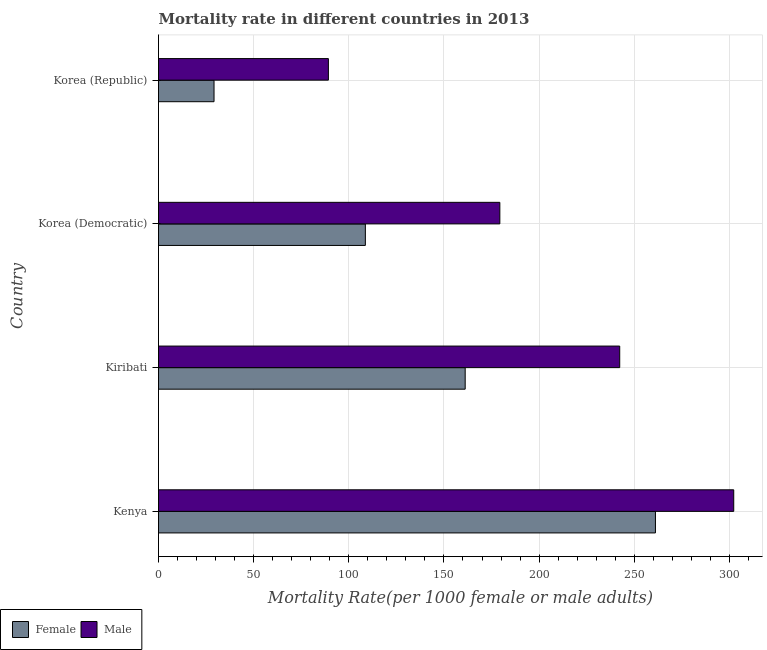How many groups of bars are there?
Keep it short and to the point. 4. How many bars are there on the 1st tick from the bottom?
Make the answer very short. 2. What is the label of the 4th group of bars from the top?
Make the answer very short. Kenya. What is the male mortality rate in Korea (Democratic)?
Your answer should be compact. 179.37. Across all countries, what is the maximum female mortality rate?
Keep it short and to the point. 261.13. Across all countries, what is the minimum male mortality rate?
Offer a terse response. 89.27. In which country was the male mortality rate maximum?
Your response must be concise. Kenya. In which country was the male mortality rate minimum?
Provide a succinct answer. Korea (Republic). What is the total male mortality rate in the graph?
Your answer should be compact. 813.26. What is the difference between the female mortality rate in Korea (Democratic) and that in Korea (Republic)?
Your answer should be compact. 79.52. What is the difference between the female mortality rate in Korea (Democratic) and the male mortality rate in Kiribati?
Provide a short and direct response. -133.66. What is the average male mortality rate per country?
Your response must be concise. 203.32. What is the difference between the male mortality rate and female mortality rate in Kenya?
Keep it short and to the point. 41.14. What is the ratio of the female mortality rate in Kenya to that in Korea (Republic)?
Offer a very short reply. 8.95. What is the difference between the highest and the second highest male mortality rate?
Give a very brief answer. 59.92. What is the difference between the highest and the lowest male mortality rate?
Offer a very short reply. 213. In how many countries, is the male mortality rate greater than the average male mortality rate taken over all countries?
Provide a short and direct response. 2. What does the 1st bar from the top in Kiribati represents?
Make the answer very short. Male. Are all the bars in the graph horizontal?
Provide a succinct answer. Yes. How many countries are there in the graph?
Offer a terse response. 4. What is the difference between two consecutive major ticks on the X-axis?
Provide a short and direct response. 50. Where does the legend appear in the graph?
Make the answer very short. Bottom left. How many legend labels are there?
Your response must be concise. 2. What is the title of the graph?
Your response must be concise. Mortality rate in different countries in 2013. Does "Savings" appear as one of the legend labels in the graph?
Your answer should be very brief. No. What is the label or title of the X-axis?
Your response must be concise. Mortality Rate(per 1000 female or male adults). What is the Mortality Rate(per 1000 female or male adults) in Female in Kenya?
Your answer should be compact. 261.13. What is the Mortality Rate(per 1000 female or male adults) in Male in Kenya?
Your answer should be compact. 302.27. What is the Mortality Rate(per 1000 female or male adults) in Female in Kiribati?
Ensure brevity in your answer.  161.15. What is the Mortality Rate(per 1000 female or male adults) of Male in Kiribati?
Provide a succinct answer. 242.35. What is the Mortality Rate(per 1000 female or male adults) of Female in Korea (Democratic)?
Your answer should be compact. 108.69. What is the Mortality Rate(per 1000 female or male adults) of Male in Korea (Democratic)?
Provide a short and direct response. 179.37. What is the Mortality Rate(per 1000 female or male adults) in Female in Korea (Republic)?
Your response must be concise. 29.17. What is the Mortality Rate(per 1000 female or male adults) of Male in Korea (Republic)?
Keep it short and to the point. 89.27. Across all countries, what is the maximum Mortality Rate(per 1000 female or male adults) in Female?
Provide a short and direct response. 261.13. Across all countries, what is the maximum Mortality Rate(per 1000 female or male adults) in Male?
Give a very brief answer. 302.27. Across all countries, what is the minimum Mortality Rate(per 1000 female or male adults) of Female?
Offer a very short reply. 29.17. Across all countries, what is the minimum Mortality Rate(per 1000 female or male adults) in Male?
Your answer should be very brief. 89.27. What is the total Mortality Rate(per 1000 female or male adults) in Female in the graph?
Provide a short and direct response. 560.14. What is the total Mortality Rate(per 1000 female or male adults) in Male in the graph?
Give a very brief answer. 813.26. What is the difference between the Mortality Rate(per 1000 female or male adults) of Female in Kenya and that in Kiribati?
Offer a very short reply. 99.98. What is the difference between the Mortality Rate(per 1000 female or male adults) in Male in Kenya and that in Kiribati?
Make the answer very short. 59.92. What is the difference between the Mortality Rate(per 1000 female or male adults) of Female in Kenya and that in Korea (Democratic)?
Your answer should be very brief. 152.44. What is the difference between the Mortality Rate(per 1000 female or male adults) in Male in Kenya and that in Korea (Democratic)?
Provide a short and direct response. 122.9. What is the difference between the Mortality Rate(per 1000 female or male adults) in Female in Kenya and that in Korea (Republic)?
Your response must be concise. 231.96. What is the difference between the Mortality Rate(per 1000 female or male adults) in Male in Kenya and that in Korea (Republic)?
Ensure brevity in your answer.  213. What is the difference between the Mortality Rate(per 1000 female or male adults) in Female in Kiribati and that in Korea (Democratic)?
Your answer should be compact. 52.46. What is the difference between the Mortality Rate(per 1000 female or male adults) in Male in Kiribati and that in Korea (Democratic)?
Your answer should be very brief. 62.99. What is the difference between the Mortality Rate(per 1000 female or male adults) in Female in Kiribati and that in Korea (Republic)?
Make the answer very short. 131.98. What is the difference between the Mortality Rate(per 1000 female or male adults) of Male in Kiribati and that in Korea (Republic)?
Provide a succinct answer. 153.08. What is the difference between the Mortality Rate(per 1000 female or male adults) in Female in Korea (Democratic) and that in Korea (Republic)?
Ensure brevity in your answer.  79.52. What is the difference between the Mortality Rate(per 1000 female or male adults) in Male in Korea (Democratic) and that in Korea (Republic)?
Your answer should be compact. 90.1. What is the difference between the Mortality Rate(per 1000 female or male adults) in Female in Kenya and the Mortality Rate(per 1000 female or male adults) in Male in Kiribati?
Your answer should be compact. 18.77. What is the difference between the Mortality Rate(per 1000 female or male adults) of Female in Kenya and the Mortality Rate(per 1000 female or male adults) of Male in Korea (Democratic)?
Keep it short and to the point. 81.76. What is the difference between the Mortality Rate(per 1000 female or male adults) in Female in Kenya and the Mortality Rate(per 1000 female or male adults) in Male in Korea (Republic)?
Offer a terse response. 171.86. What is the difference between the Mortality Rate(per 1000 female or male adults) of Female in Kiribati and the Mortality Rate(per 1000 female or male adults) of Male in Korea (Democratic)?
Make the answer very short. -18.22. What is the difference between the Mortality Rate(per 1000 female or male adults) of Female in Kiribati and the Mortality Rate(per 1000 female or male adults) of Male in Korea (Republic)?
Offer a very short reply. 71.88. What is the difference between the Mortality Rate(per 1000 female or male adults) in Female in Korea (Democratic) and the Mortality Rate(per 1000 female or male adults) in Male in Korea (Republic)?
Offer a terse response. 19.42. What is the average Mortality Rate(per 1000 female or male adults) in Female per country?
Ensure brevity in your answer.  140.04. What is the average Mortality Rate(per 1000 female or male adults) of Male per country?
Offer a very short reply. 203.32. What is the difference between the Mortality Rate(per 1000 female or male adults) of Female and Mortality Rate(per 1000 female or male adults) of Male in Kenya?
Keep it short and to the point. -41.14. What is the difference between the Mortality Rate(per 1000 female or male adults) of Female and Mortality Rate(per 1000 female or male adults) of Male in Kiribati?
Keep it short and to the point. -81.2. What is the difference between the Mortality Rate(per 1000 female or male adults) of Female and Mortality Rate(per 1000 female or male adults) of Male in Korea (Democratic)?
Give a very brief answer. -70.68. What is the difference between the Mortality Rate(per 1000 female or male adults) of Female and Mortality Rate(per 1000 female or male adults) of Male in Korea (Republic)?
Offer a very short reply. -60.1. What is the ratio of the Mortality Rate(per 1000 female or male adults) of Female in Kenya to that in Kiribati?
Offer a very short reply. 1.62. What is the ratio of the Mortality Rate(per 1000 female or male adults) in Male in Kenya to that in Kiribati?
Provide a succinct answer. 1.25. What is the ratio of the Mortality Rate(per 1000 female or male adults) of Female in Kenya to that in Korea (Democratic)?
Offer a terse response. 2.4. What is the ratio of the Mortality Rate(per 1000 female or male adults) in Male in Kenya to that in Korea (Democratic)?
Keep it short and to the point. 1.69. What is the ratio of the Mortality Rate(per 1000 female or male adults) of Female in Kenya to that in Korea (Republic)?
Keep it short and to the point. 8.95. What is the ratio of the Mortality Rate(per 1000 female or male adults) of Male in Kenya to that in Korea (Republic)?
Make the answer very short. 3.39. What is the ratio of the Mortality Rate(per 1000 female or male adults) in Female in Kiribati to that in Korea (Democratic)?
Offer a terse response. 1.48. What is the ratio of the Mortality Rate(per 1000 female or male adults) of Male in Kiribati to that in Korea (Democratic)?
Provide a succinct answer. 1.35. What is the ratio of the Mortality Rate(per 1000 female or male adults) in Female in Kiribati to that in Korea (Republic)?
Provide a succinct answer. 5.52. What is the ratio of the Mortality Rate(per 1000 female or male adults) of Male in Kiribati to that in Korea (Republic)?
Keep it short and to the point. 2.71. What is the ratio of the Mortality Rate(per 1000 female or male adults) in Female in Korea (Democratic) to that in Korea (Republic)?
Give a very brief answer. 3.73. What is the ratio of the Mortality Rate(per 1000 female or male adults) in Male in Korea (Democratic) to that in Korea (Republic)?
Offer a very short reply. 2.01. What is the difference between the highest and the second highest Mortality Rate(per 1000 female or male adults) of Female?
Give a very brief answer. 99.98. What is the difference between the highest and the second highest Mortality Rate(per 1000 female or male adults) in Male?
Your answer should be very brief. 59.92. What is the difference between the highest and the lowest Mortality Rate(per 1000 female or male adults) of Female?
Keep it short and to the point. 231.96. What is the difference between the highest and the lowest Mortality Rate(per 1000 female or male adults) of Male?
Provide a short and direct response. 213. 